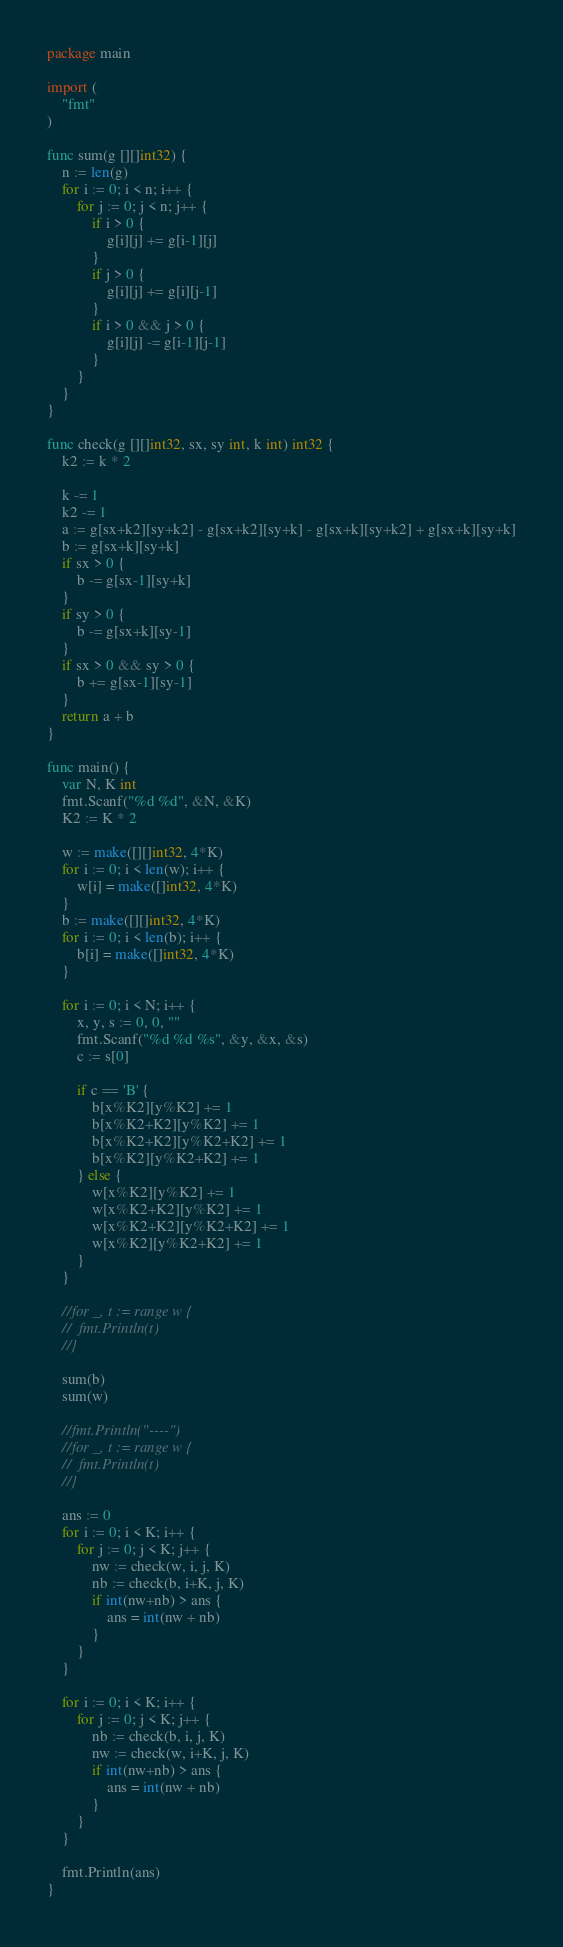Convert code to text. <code><loc_0><loc_0><loc_500><loc_500><_Go_>package main

import (
	"fmt"
)

func sum(g [][]int32) {
	n := len(g)
	for i := 0; i < n; i++ {
		for j := 0; j < n; j++ {
			if i > 0 {
				g[i][j] += g[i-1][j]
			}
			if j > 0 {
				g[i][j] += g[i][j-1]
			}
			if i > 0 && j > 0 {
				g[i][j] -= g[i-1][j-1]
			}
		}
	}
}

func check(g [][]int32, sx, sy int, k int) int32 {
	k2 := k * 2

	k -= 1
	k2 -= 1
	a := g[sx+k2][sy+k2] - g[sx+k2][sy+k] - g[sx+k][sy+k2] + g[sx+k][sy+k]
	b := g[sx+k][sy+k]
	if sx > 0 {
		b -= g[sx-1][sy+k]
	}
	if sy > 0 {
		b -= g[sx+k][sy-1]
	}
	if sx > 0 && sy > 0 {
		b += g[sx-1][sy-1]
	}
	return a + b
}

func main() {
	var N, K int
	fmt.Scanf("%d %d", &N, &K)
	K2 := K * 2

	w := make([][]int32, 4*K)
	for i := 0; i < len(w); i++ {
		w[i] = make([]int32, 4*K)
	}
	b := make([][]int32, 4*K)
	for i := 0; i < len(b); i++ {
		b[i] = make([]int32, 4*K)
	}

	for i := 0; i < N; i++ {
		x, y, s := 0, 0, ""
		fmt.Scanf("%d %d %s", &y, &x, &s)
		c := s[0]

		if c == 'B' {
			b[x%K2][y%K2] += 1
			b[x%K2+K2][y%K2] += 1
			b[x%K2+K2][y%K2+K2] += 1
			b[x%K2][y%K2+K2] += 1
		} else {
			w[x%K2][y%K2] += 1
			w[x%K2+K2][y%K2] += 1
			w[x%K2+K2][y%K2+K2] += 1
			w[x%K2][y%K2+K2] += 1
		}
	}

	//for _, t := range w {
	//	fmt.Println(t)
	//}

	sum(b)
	sum(w)

	//fmt.Println("----")
	//for _, t := range w {
	//	fmt.Println(t)
	//}

	ans := 0
	for i := 0; i < K; i++ {
		for j := 0; j < K; j++ {
			nw := check(w, i, j, K)
			nb := check(b, i+K, j, K)
			if int(nw+nb) > ans {
				ans = int(nw + nb)
			}
		}
	}

	for i := 0; i < K; i++ {
		for j := 0; j < K; j++ {
			nb := check(b, i, j, K)
			nw := check(w, i+K, j, K)
			if int(nw+nb) > ans {
				ans = int(nw + nb)
			}
		}
	}

	fmt.Println(ans)
}
</code> 